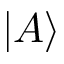<formula> <loc_0><loc_0><loc_500><loc_500>| A \rangle</formula> 